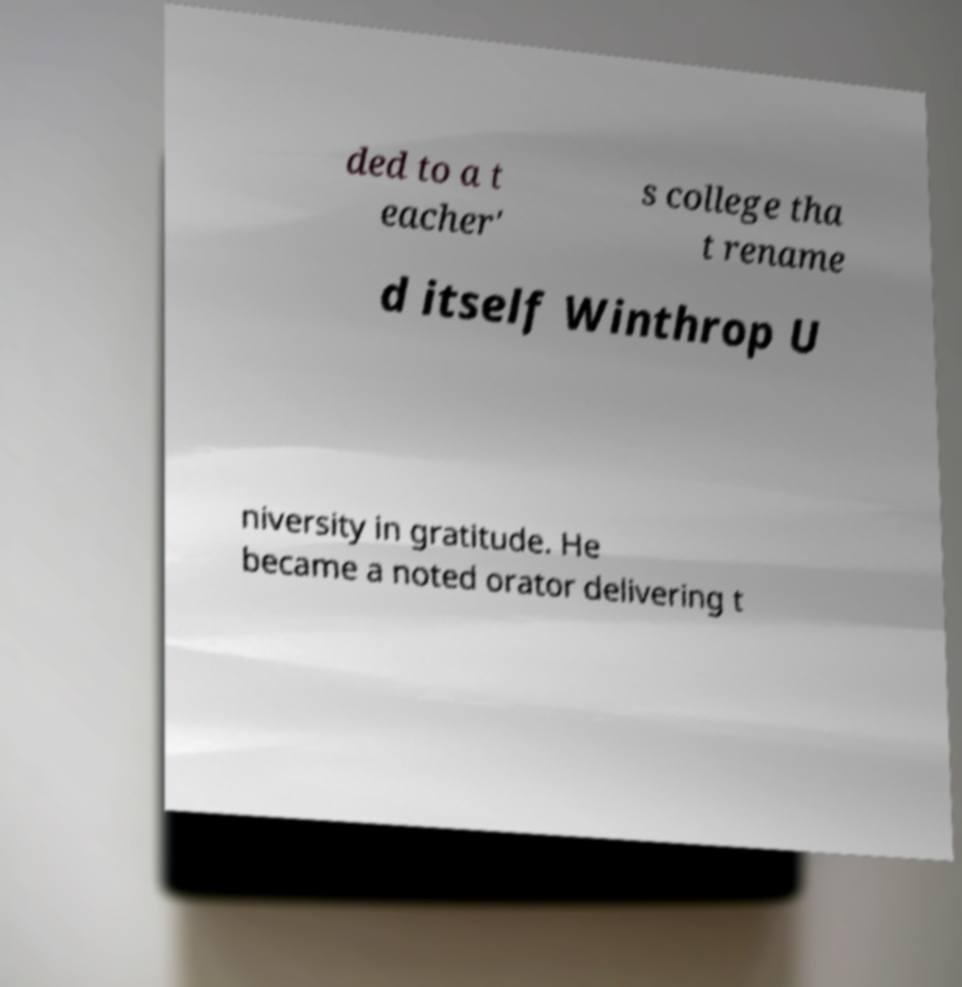Could you extract and type out the text from this image? ded to a t eacher' s college tha t rename d itself Winthrop U niversity in gratitude. He became a noted orator delivering t 